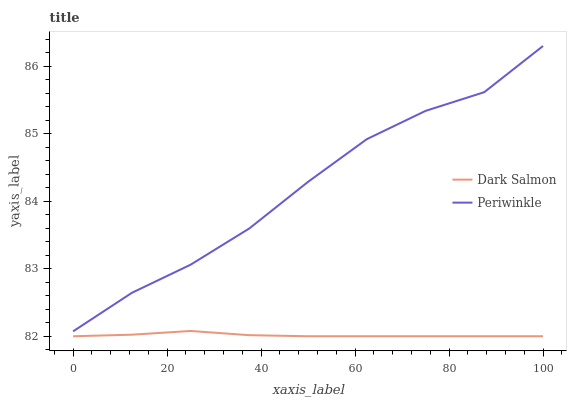Does Dark Salmon have the minimum area under the curve?
Answer yes or no. Yes. Does Periwinkle have the maximum area under the curve?
Answer yes or no. Yes. Does Dark Salmon have the maximum area under the curve?
Answer yes or no. No. Is Dark Salmon the smoothest?
Answer yes or no. Yes. Is Periwinkle the roughest?
Answer yes or no. Yes. Is Dark Salmon the roughest?
Answer yes or no. No. Does Dark Salmon have the lowest value?
Answer yes or no. Yes. Does Periwinkle have the highest value?
Answer yes or no. Yes. Does Dark Salmon have the highest value?
Answer yes or no. No. Is Dark Salmon less than Periwinkle?
Answer yes or no. Yes. Is Periwinkle greater than Dark Salmon?
Answer yes or no. Yes. Does Dark Salmon intersect Periwinkle?
Answer yes or no. No. 